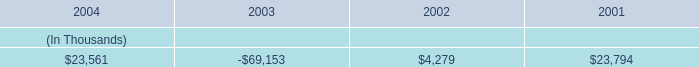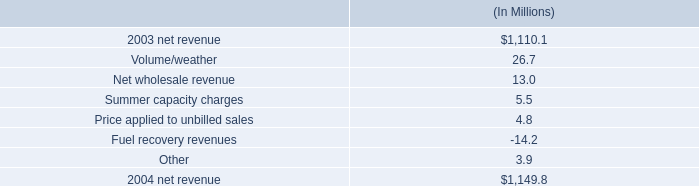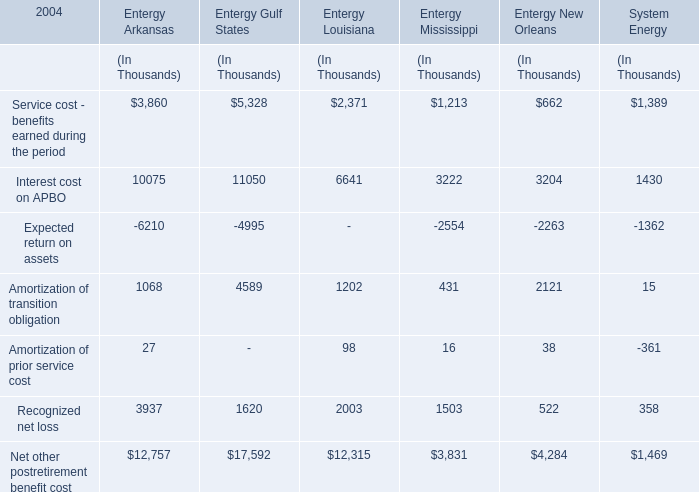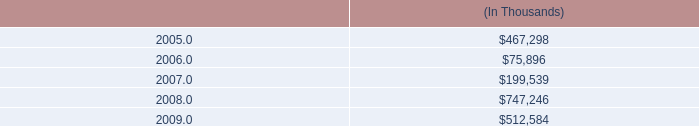what is the growth rate in net revenue in 2004 for entergy gulf states , inc? 
Computations: ((1149.8 - 1110.1) / 1110.1)
Answer: 0.03576. 